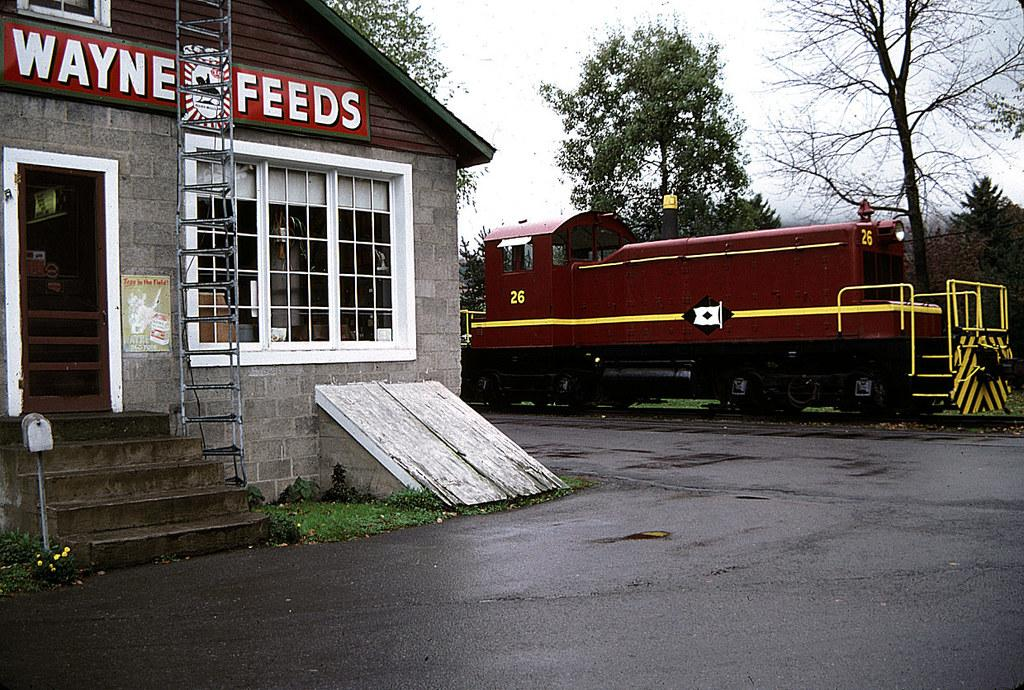What type of structure is visible in the image? There is a building in the image. Can you describe any specific features of the building? There is a window and stairs visible in the image. What type of vehicle can be seen in the image? There is a vehicle in the image, with yellow and maroon colors. What other natural elements are present in the image? There are trees in the image. How would you describe the sky in the image? The sky appears to be white in color. Where is the meeting taking place in the image? There is no meeting taking place in the image. Can you see any fish in the image? There are no fish present in the image. 